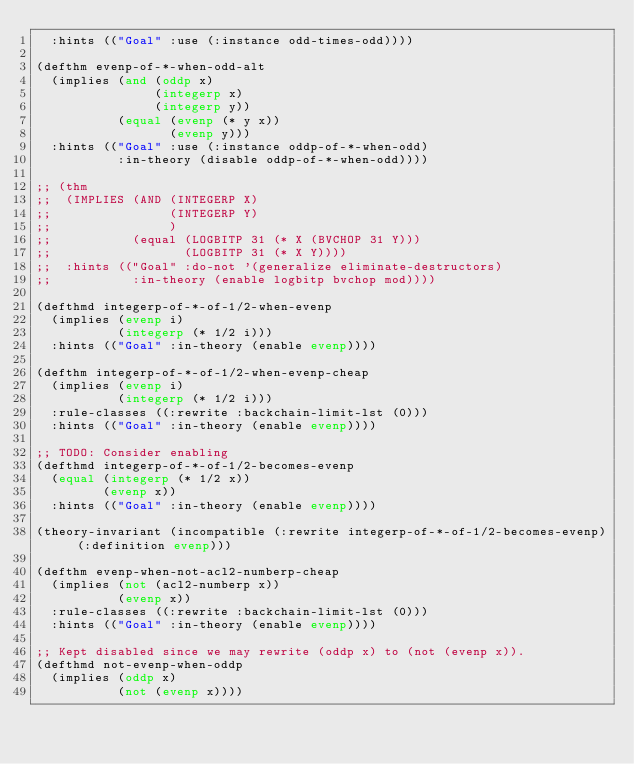Convert code to text. <code><loc_0><loc_0><loc_500><loc_500><_Lisp_>  :hints (("Goal" :use (:instance odd-times-odd))))

(defthm evenp-of-*-when-odd-alt
  (implies (and (oddp x)
                (integerp x)
                (integerp y))
           (equal (evenp (* y x))
                  (evenp y)))
  :hints (("Goal" :use (:instance oddp-of-*-when-odd)
           :in-theory (disable oddp-of-*-when-odd))))

;; (thm
;;  (IMPLIES (AND (INTEGERP X)
;;                (INTEGERP Y)
;;                )
;;           (equal (LOGBITP 31 (* X (BVCHOP 31 Y)))
;;                  (LOGBITP 31 (* X Y))))
;;  :hints (("Goal" :do-not '(generalize eliminate-destructors)
;;           :in-theory (enable logbitp bvchop mod))))

(defthmd integerp-of-*-of-1/2-when-evenp
  (implies (evenp i)
           (integerp (* 1/2 i)))
  :hints (("Goal" :in-theory (enable evenp))))

(defthm integerp-of-*-of-1/2-when-evenp-cheap
  (implies (evenp i)
           (integerp (* 1/2 i)))
  :rule-classes ((:rewrite :backchain-limit-lst (0)))
  :hints (("Goal" :in-theory (enable evenp))))

;; TODO: Consider enabling
(defthmd integerp-of-*-of-1/2-becomes-evenp
  (equal (integerp (* 1/2 x))
         (evenp x))
  :hints (("Goal" :in-theory (enable evenp))))

(theory-invariant (incompatible (:rewrite integerp-of-*-of-1/2-becomes-evenp) (:definition evenp)))

(defthm evenp-when-not-acl2-numberp-cheap
  (implies (not (acl2-numberp x))
           (evenp x))
  :rule-classes ((:rewrite :backchain-limit-lst (0)))
  :hints (("Goal" :in-theory (enable evenp))))

;; Kept disabled since we may rewrite (oddp x) to (not (evenp x)).
(defthmd not-evenp-when-oddp
  (implies (oddp x)
           (not (evenp x))))
</code> 